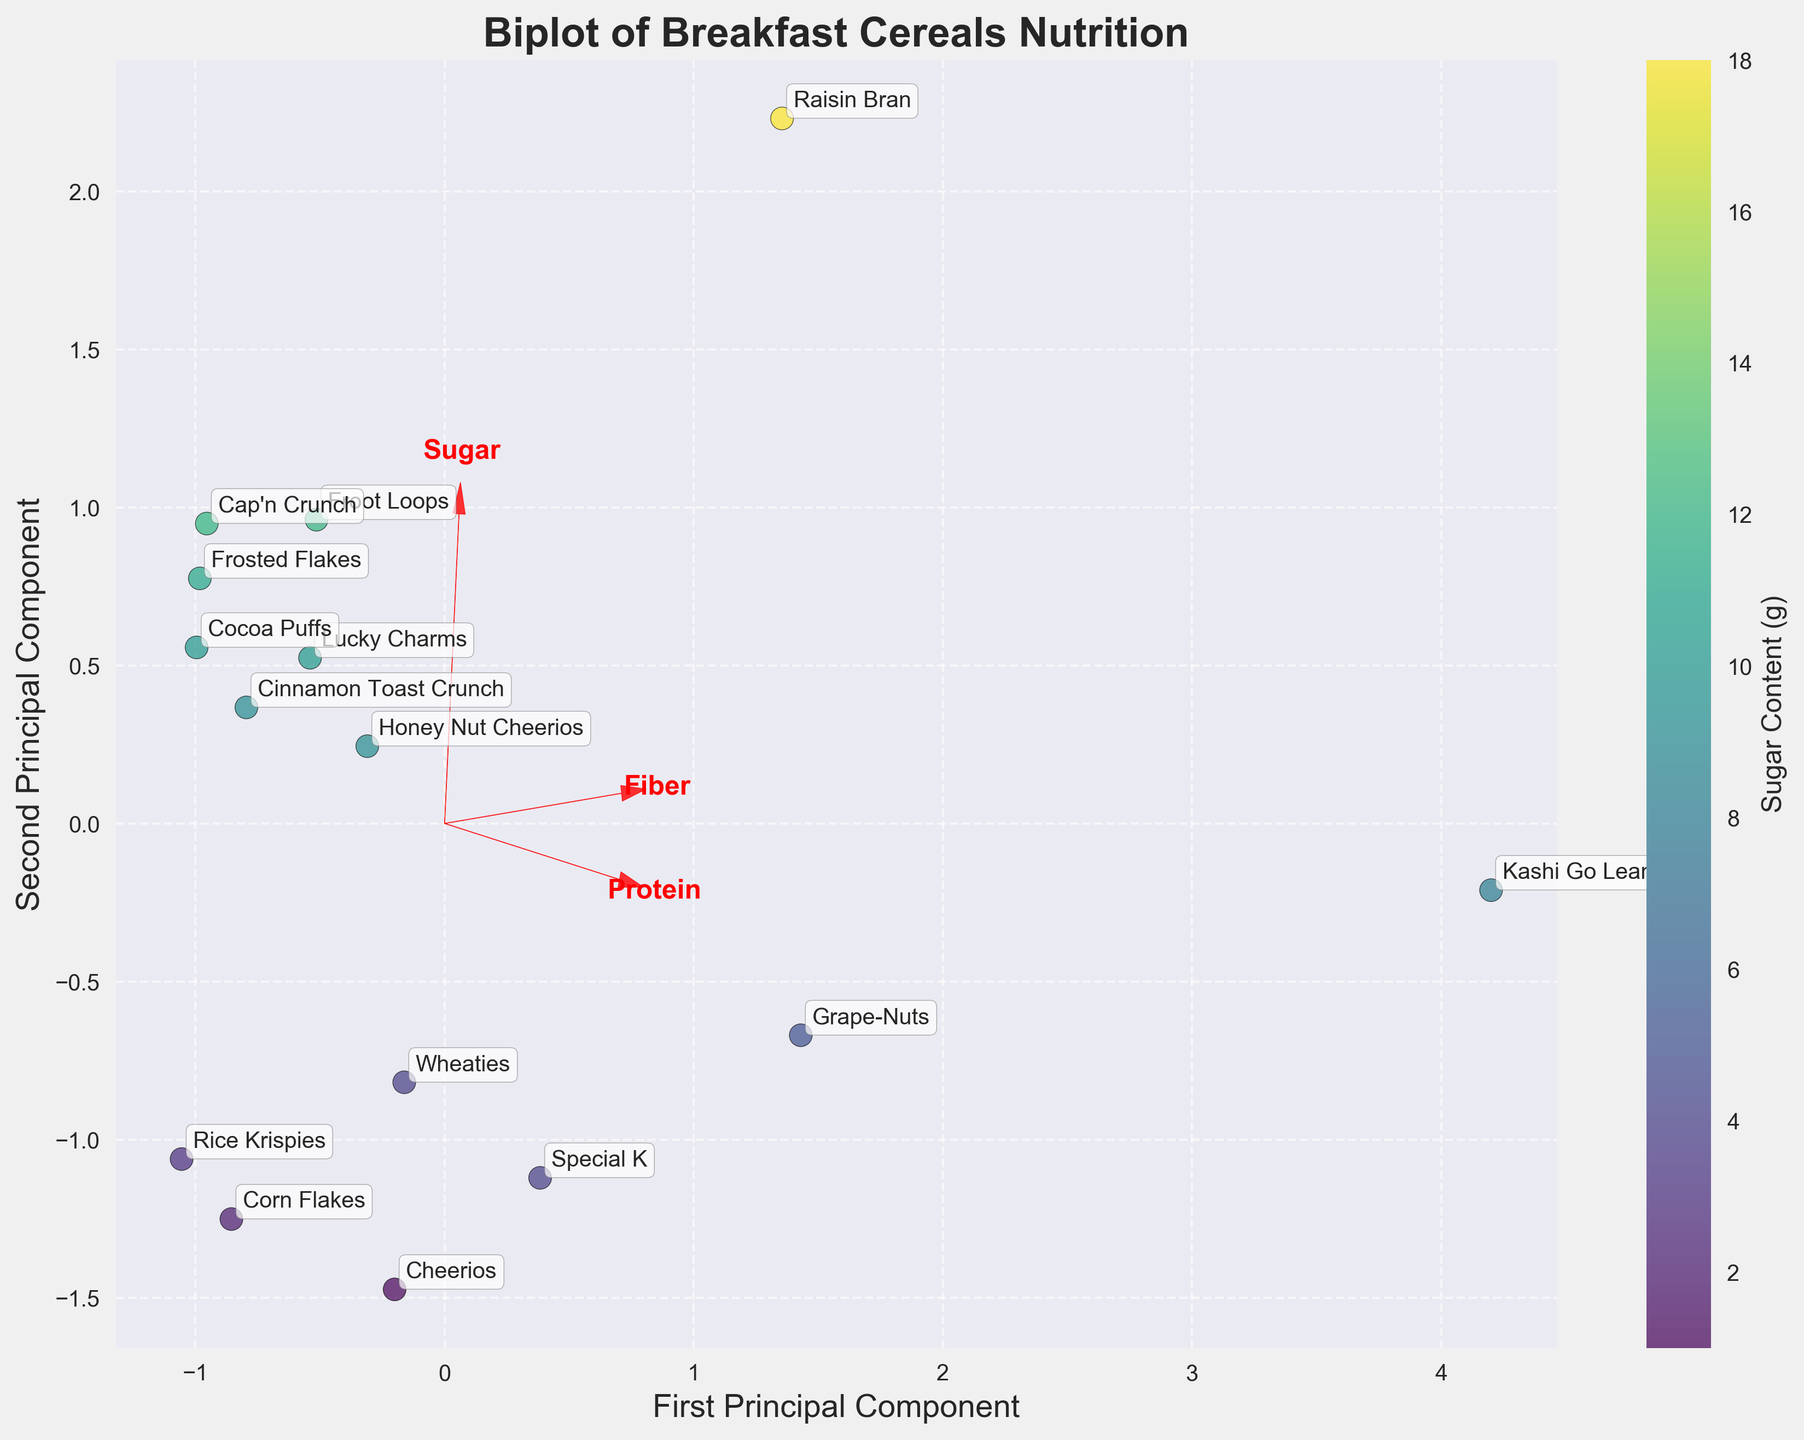What is the title of the figure? The title of the figure is located at the top center of the plot. By looking at the plot, you can read the text of the title.
Answer: Biplot of Breakfast Cereals Nutrition How many cereals are plotted in the figure? You can count the number of data points, each annotated with cereal names. Each point represents one cereal.
Answer: 15 Which cereal has the highest sugar content and where is it located in the plot? Raisin Bran has the highest sugar content of 18 grams. On the plot, it's a data point located toward the right side, typically annotated.
Answer: Raisin Bran Which cereals are positioned nearest to the origin (0,0) of the plot? By visually inspecting the plot, you can see that Corn Flakes and Rice Krispies are closest to the origin, reflecting their similar nutritional content in terms of the first two principal components.
Answer: Corn Flakes and Rice Krispies Which cereal has a high fiber content but relatively low sugar content compared to others? The feature vector "Fiber" helps interpret this; Kashi Go Lean, positioned near the arrow pointing towards high fiber, but not along with high sugar content, matches this description.
Answer: Kashi Go Lean Which cereals are positioned farthest apart on the first principal component? By examining the spread along the horizontal axis (first principal component), Raisin Bran (far right) and Rice Krispies (far left) are the farthest apart.
Answer: Raisin Bran and Rice Krispies Is there a cereal with high protein content and low sugar content? If so, name it. Using the feature vector "Protein," Special K stands out for its high protein but relatively lower sugar content. Its position relative to both vectors can be verified on the plot.
Answer: Special K Compare the positions of Froot Loops and Cheerios on the plot. Which one is closer to the origin, and what does that indicate about their nutritional content relative to the principal components? By comparing, Cheerios is closer to the origin, indicating its nutritional content in terms of sugar, fiber, and protein is more central or average compared to Froot Loops, which is further away.
Answer: Cheerios Which two cereals are most similar in their nutritional content based on their positions in the plot? Looking at clusters or proximity in the plot, Frosted Flakes and Cocoa Puffs are very close to each other, suggesting similar nutritional profiles in the dimensions of sugar, fiber, and protein.
Answer: Frosted Flakes and Cocoa Puffs 